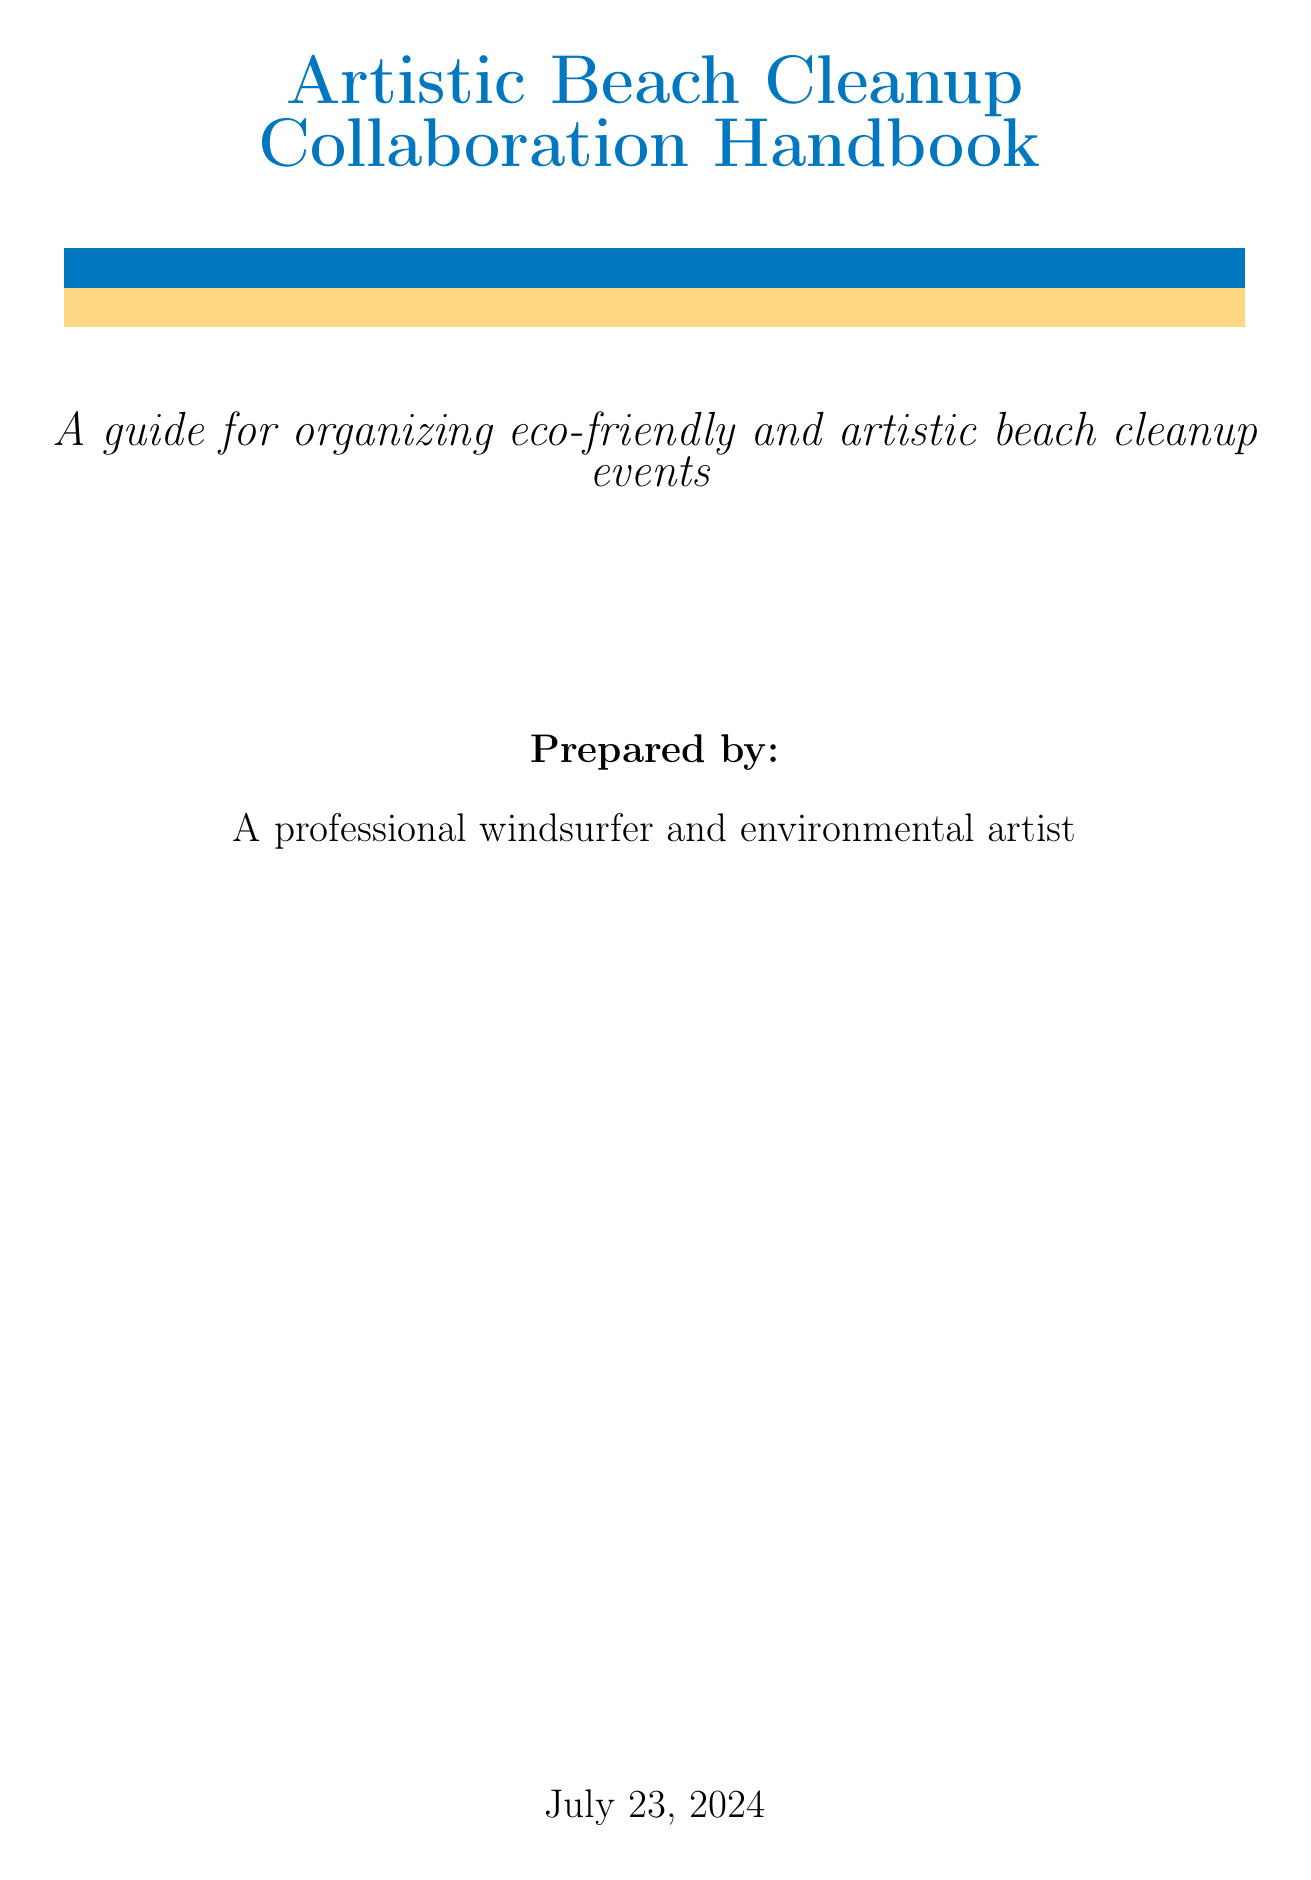what is the title of the handbook? The title of the handbook is clearly stated on the title page of the document.
Answer: Artistic Beach Cleanup Collaboration Handbook which beach is suggested for the event location? The document includes a specific example of a beach location suitable for the event.
Answer: Maui's Ho'okipa Beach Park what type of event competition is mentioned in the Artistic Elements section? This question relates to the activities that engage participants through artistic expression during the cleanup event.
Answer: beach art competition what are the first aid supplies listed in the Equipment and Supplies section? The document specifically lists types of supplies needed for the event preparation.
Answer: first aid kits and sunscreen how many appendices does the handbook include? The total number of appendices in the document is explicitly mentioned in the Table of Contents.
Answer: 2 what is the purpose of the post-event activities? This question asks for an understanding of the objectives laid out for after the main event is completed.
Answer: Organizing a beachside art exhibition with collected items what should be included in thank-you messages post-event? This question relates to the follow-up steps after the event concludes.
Answer: messaging participants and sponsors which local organization is mentioned in the Resources and Contacts section? The document provides examples of organizations relevant to the event.
Answer: Maui Ocean Center Marine Institute 